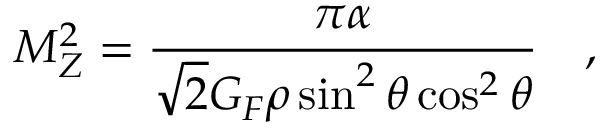Convert formula to latex. <formula><loc_0><loc_0><loc_500><loc_500>M _ { Z } ^ { 2 } = \frac { \pi \alpha } { \sqrt { 2 } G _ { F } \rho \sin ^ { 2 } \theta \cos ^ { 2 } \theta ,</formula> 